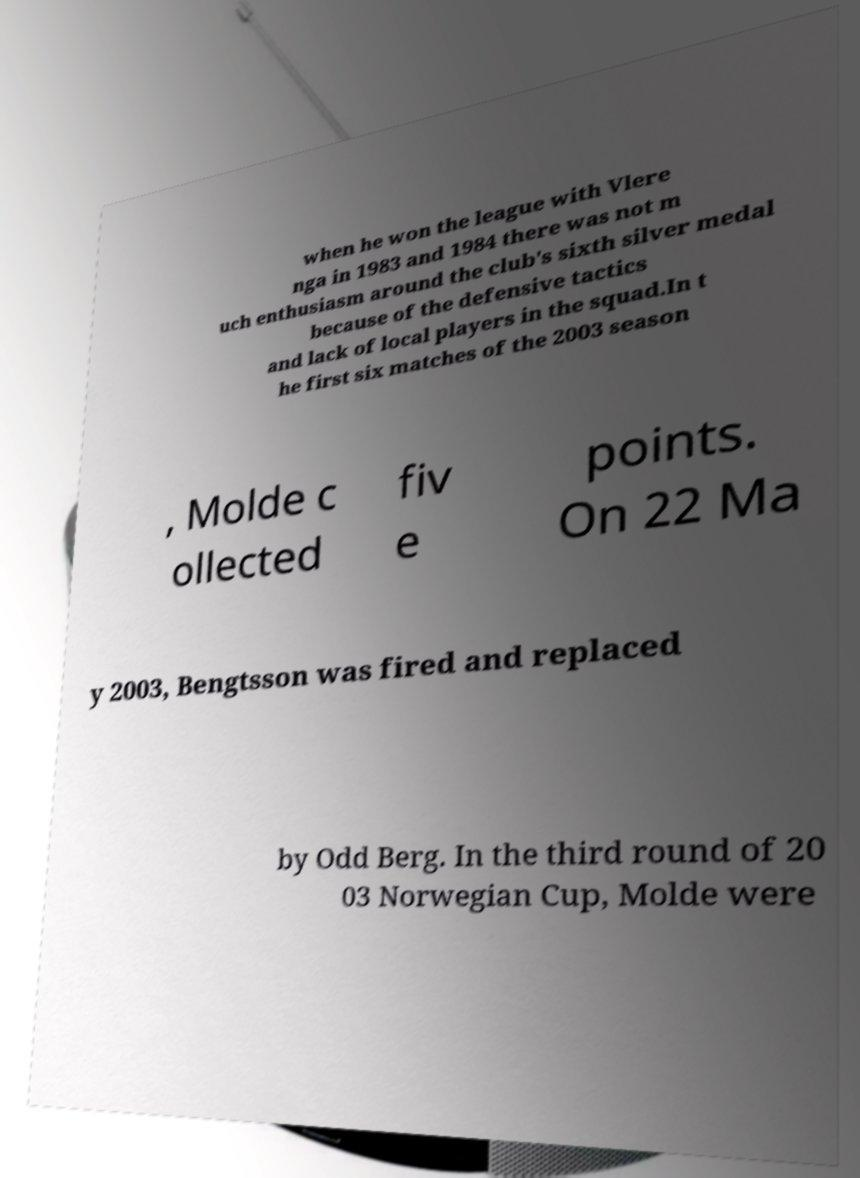I need the written content from this picture converted into text. Can you do that? when he won the league with Vlere nga in 1983 and 1984 there was not m uch enthusiasm around the club's sixth silver medal because of the defensive tactics and lack of local players in the squad.In t he first six matches of the 2003 season , Molde c ollected fiv e points. On 22 Ma y 2003, Bengtsson was fired and replaced by Odd Berg. In the third round of 20 03 Norwegian Cup, Molde were 